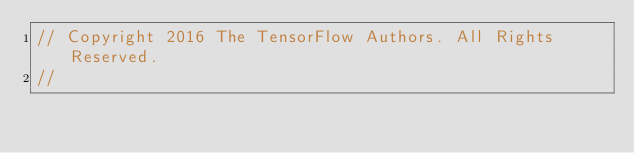Convert code to text. <code><loc_0><loc_0><loc_500><loc_500><_Go_>// Copyright 2016 The TensorFlow Authors. All Rights Reserved.
//</code> 